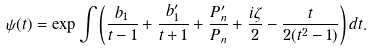Convert formula to latex. <formula><loc_0><loc_0><loc_500><loc_500>\psi ( t ) = \exp \int \left ( \frac { b _ { 1 } } { t - 1 } + \frac { b ^ { \prime } _ { 1 } } { t + 1 } + \frac { P ^ { \prime } _ { n } } { P _ { n } } + \frac { i \zeta } { 2 } - \frac { t } { 2 ( t ^ { 2 } - 1 ) } \right ) d t .</formula> 